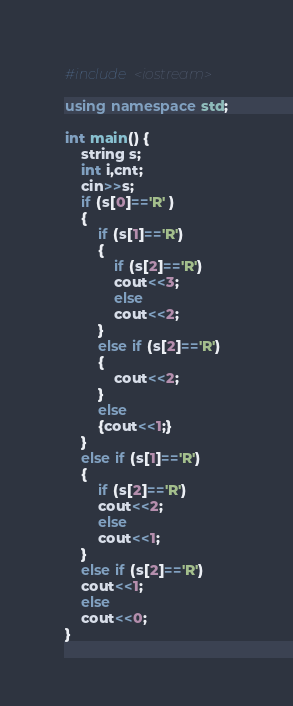<code> <loc_0><loc_0><loc_500><loc_500><_C++_>#include <iostream>

using namespace std;

int main() {
    string s;
    int i,cnt;
    cin>>s;
    if (s[0]=='R' )
    {
        if (s[1]=='R')
        {
            if (s[2]=='R')
            cout<<3;
            else
            cout<<2;
        }
        else if (s[2]=='R')
        {
            cout<<2;
        }
        else
        {cout<<1;}
    }
    else if (s[1]=='R')
    {
        if (s[2]=='R')
        cout<<2;
        else
        cout<<1;
    }
    else if (s[2]=='R')
    cout<<1;
    else
    cout<<0;
}</code> 